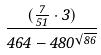Convert formula to latex. <formula><loc_0><loc_0><loc_500><loc_500>\frac { ( \frac { 7 } { 5 1 } \cdot 3 ) } { 4 6 4 - 4 8 0 ^ { \sqrt { 8 6 } } }</formula> 